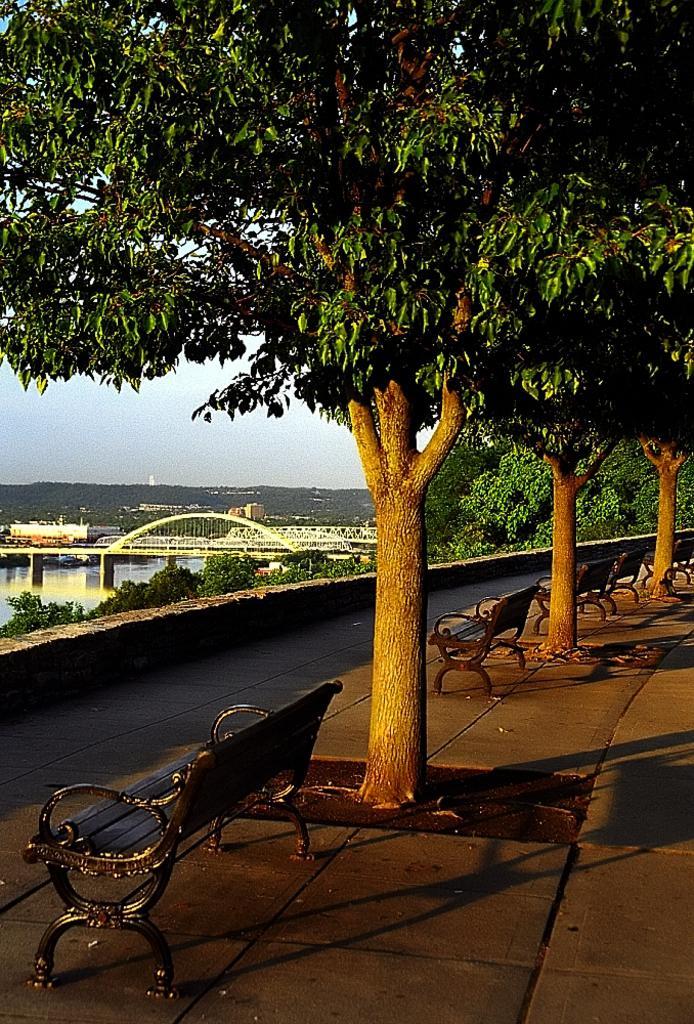Can you describe this image briefly? There are black color metal benches are present at the bottom of this image, and we can see there are some tree on the right side of this image. There is a bridge and some trees are present on the left side of this image, and there is a sky in the background. 